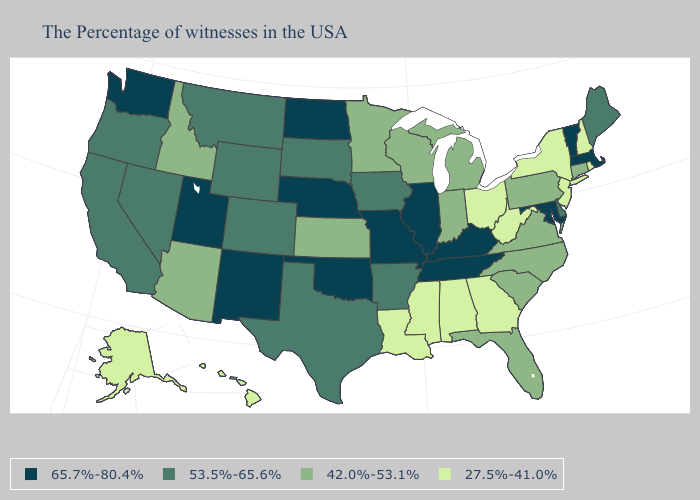Name the states that have a value in the range 65.7%-80.4%?
Quick response, please. Massachusetts, Vermont, Maryland, Kentucky, Tennessee, Illinois, Missouri, Nebraska, Oklahoma, North Dakota, New Mexico, Utah, Washington. Does the map have missing data?
Short answer required. No. Among the states that border Mississippi , does Louisiana have the highest value?
Answer briefly. No. Among the states that border Kansas , does Colorado have the lowest value?
Concise answer only. Yes. Name the states that have a value in the range 42.0%-53.1%?
Short answer required. Connecticut, Pennsylvania, Virginia, North Carolina, South Carolina, Florida, Michigan, Indiana, Wisconsin, Minnesota, Kansas, Arizona, Idaho. Name the states that have a value in the range 65.7%-80.4%?
Give a very brief answer. Massachusetts, Vermont, Maryland, Kentucky, Tennessee, Illinois, Missouri, Nebraska, Oklahoma, North Dakota, New Mexico, Utah, Washington. Name the states that have a value in the range 53.5%-65.6%?
Quick response, please. Maine, Delaware, Arkansas, Iowa, Texas, South Dakota, Wyoming, Colorado, Montana, Nevada, California, Oregon. What is the value of Hawaii?
Short answer required. 27.5%-41.0%. Among the states that border Maine , which have the lowest value?
Concise answer only. New Hampshire. Among the states that border Pennsylvania , which have the highest value?
Quick response, please. Maryland. What is the highest value in the West ?
Concise answer only. 65.7%-80.4%. Among the states that border North Carolina , which have the highest value?
Give a very brief answer. Tennessee. Among the states that border Kansas , which have the highest value?
Short answer required. Missouri, Nebraska, Oklahoma. Does Tennessee have the highest value in the USA?
Short answer required. Yes. Does Utah have the highest value in the USA?
Answer briefly. Yes. 